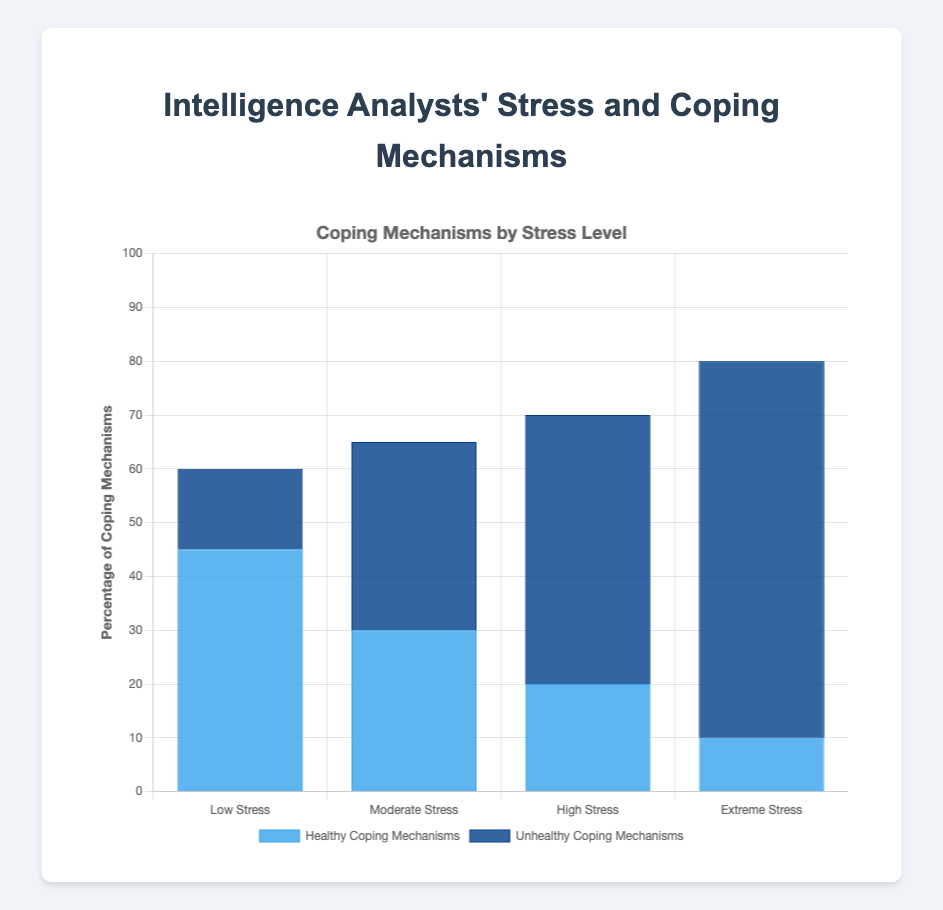What is the average number of healthy coping mechanisms for all stress levels? To find the average, sum the healthy coping mechanisms for all categories: 45 (Low Stress) + 30 (Moderate Stress) + 20 (High Stress) + 10 (Extreme Stress) = 105. Then divide by the number of categories (4). So, 105 / 4 = 26.25.
Answer: 26.25 How does the number of unhealthy coping mechanisms change from Low Stress to Extreme Stress? Subtract the number of unhealthy coping mechanisms for Low Stress from that for Extreme Stress: 70 (Extreme Stress) - 15 (Low Stress) = 55.
Answer: Increase by 55 Which stress level has the highest percentage of unhealthy coping mechanisms? The bar representing unhealthy coping mechanisms is tallest at the Extreme Stress level, reaching 70%.
Answer: Extreme Stress What is the difference in healthy coping mechanisms between Moderate Stress and High Stress levels? Subtract the healthy coping mechanisms for High Stress from those for Moderate Stress: 30 (Moderate Stress) - 20 (High Stress) = 10.
Answer: 10 Which category has more healthy coping mechanisms: Low Stress or Moderate Stress? Compare the healthy coping mechanisms for Low Stress (45) with those for Moderate Stress (30). Low Stress is higher.
Answer: Low Stress If you combine both healthy and unhealthy coping mechanisms, which category has the highest total? Sum both mechanisms for each category. Low Stress: 45 + 15 = 60, Moderate Stress: 30 + 35 = 65, High Stress: 20 + 50 = 70, Extreme Stress: 10 + 70 = 80. The highest total is for Extreme Stress.
Answer: Extreme Stress What is the ratio of healthy to unhealthy coping mechanisms in the Low Stress category? For Low Stress, the ratio is 45 (healthy) to 15 (unhealthy). Simplify the ratio 45:15 by dividing both terms by 15, giving a ratio of 3:1.
Answer: 3:1 Which category shows an equal or higher number of unhealthy coping mechanisms compared to healthy ones? Compare the numbers in each category. Moderate Stress (30 healthy, 35 unhealthy), High Stress (20 healthy, 50 unhealthy), and Extreme Stress (10 healthy, 70 unhealthy) all show this.
Answer: Moderate, High, Extreme What is the visual difference in bar height between the healthy coping mechanisms of Low and Extreme Stress levels? The bar for healthy coping mechanisms at Low Stress is noticeably taller than that at Extreme Stress, specifically four times taller (45% compared to 10%).
Answer: Four times taller How much lower is the average stress level in the Low Stress category compared to the Extreme Stress category? Subtract the average stress level of Low Stress (2) from that of Extreme Stress (10): 10 - 2 = 8.
Answer: 8 